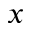<formula> <loc_0><loc_0><loc_500><loc_500>x</formula> 